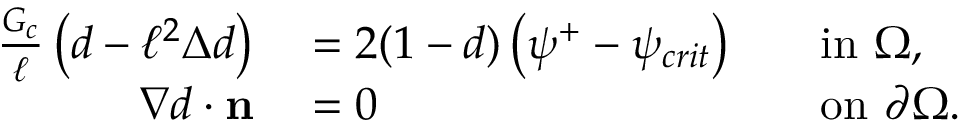Convert formula to latex. <formula><loc_0><loc_0><loc_500><loc_500>\begin{array} { r l r l } { \frac { G _ { c } } { \ell } \left ( d - \ell ^ { 2 } \Delta d \right ) } & = 2 ( 1 - d ) \left ( \psi ^ { + } - \psi _ { c r i t } \right ) } & i n \ \Omega , } \\ { \nabla d \cdot n } & = 0 } & o n \ \partial \Omega . } \end{array}</formula> 